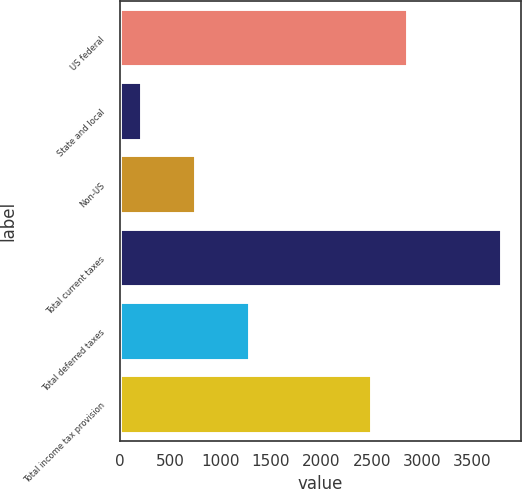Convert chart. <chart><loc_0><loc_0><loc_500><loc_500><bar_chart><fcel>US federal<fcel>State and local<fcel>Non-US<fcel>Total current taxes<fcel>Total deferred taxes<fcel>Total income tax provision<nl><fcel>2862.3<fcel>219<fcel>754<fcel>3792<fcel>1287<fcel>2505<nl></chart> 